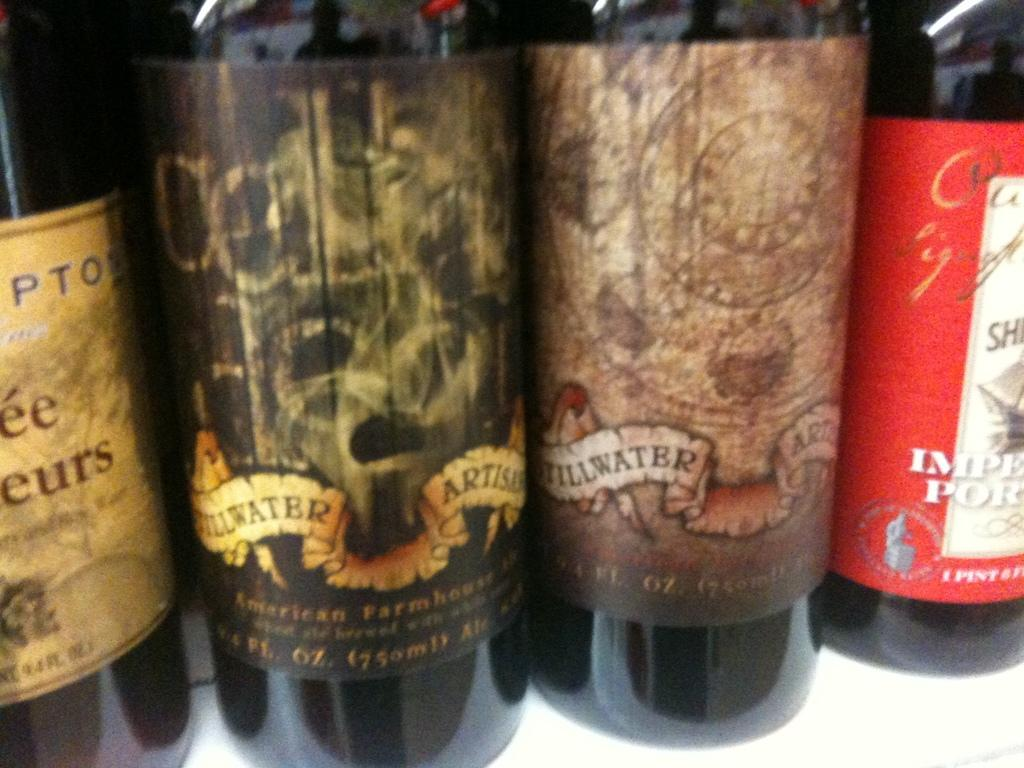<image>
Summarize the visual content of the image. Bottles with labels that says 1 pint on one of them. 